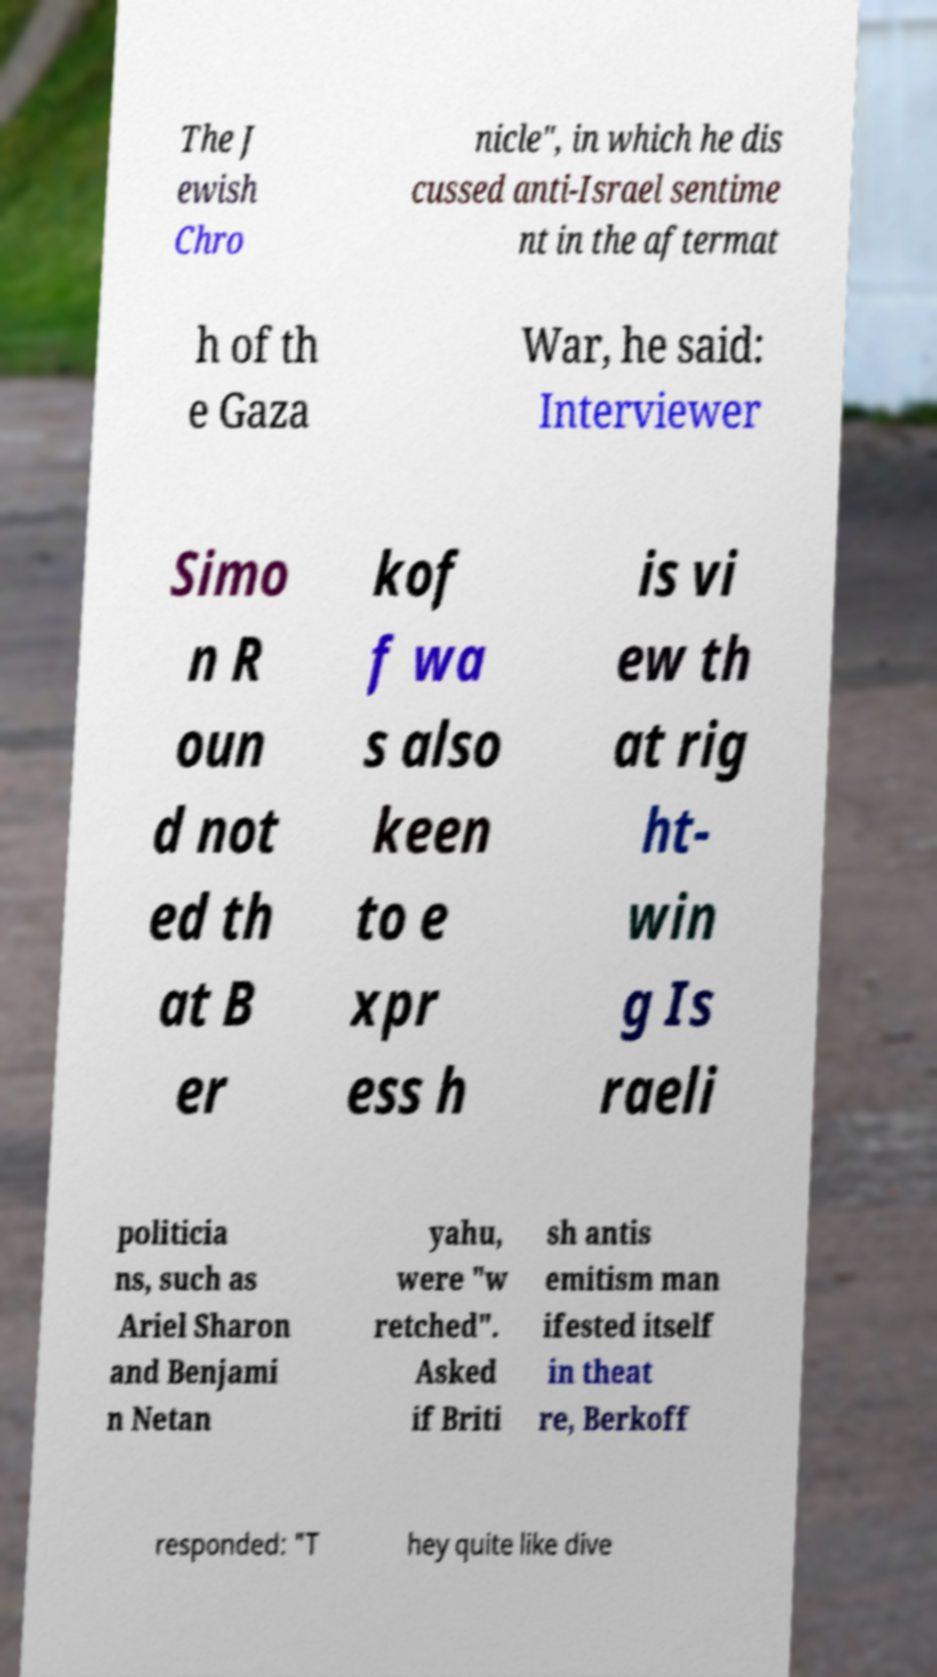Can you read and provide the text displayed in the image?This photo seems to have some interesting text. Can you extract and type it out for me? The J ewish Chro nicle", in which he dis cussed anti-Israel sentime nt in the aftermat h of th e Gaza War, he said: Interviewer Simo n R oun d not ed th at B er kof f wa s also keen to e xpr ess h is vi ew th at rig ht- win g Is raeli politicia ns, such as Ariel Sharon and Benjami n Netan yahu, were "w retched". Asked if Briti sh antis emitism man ifested itself in theat re, Berkoff responded: "T hey quite like dive 